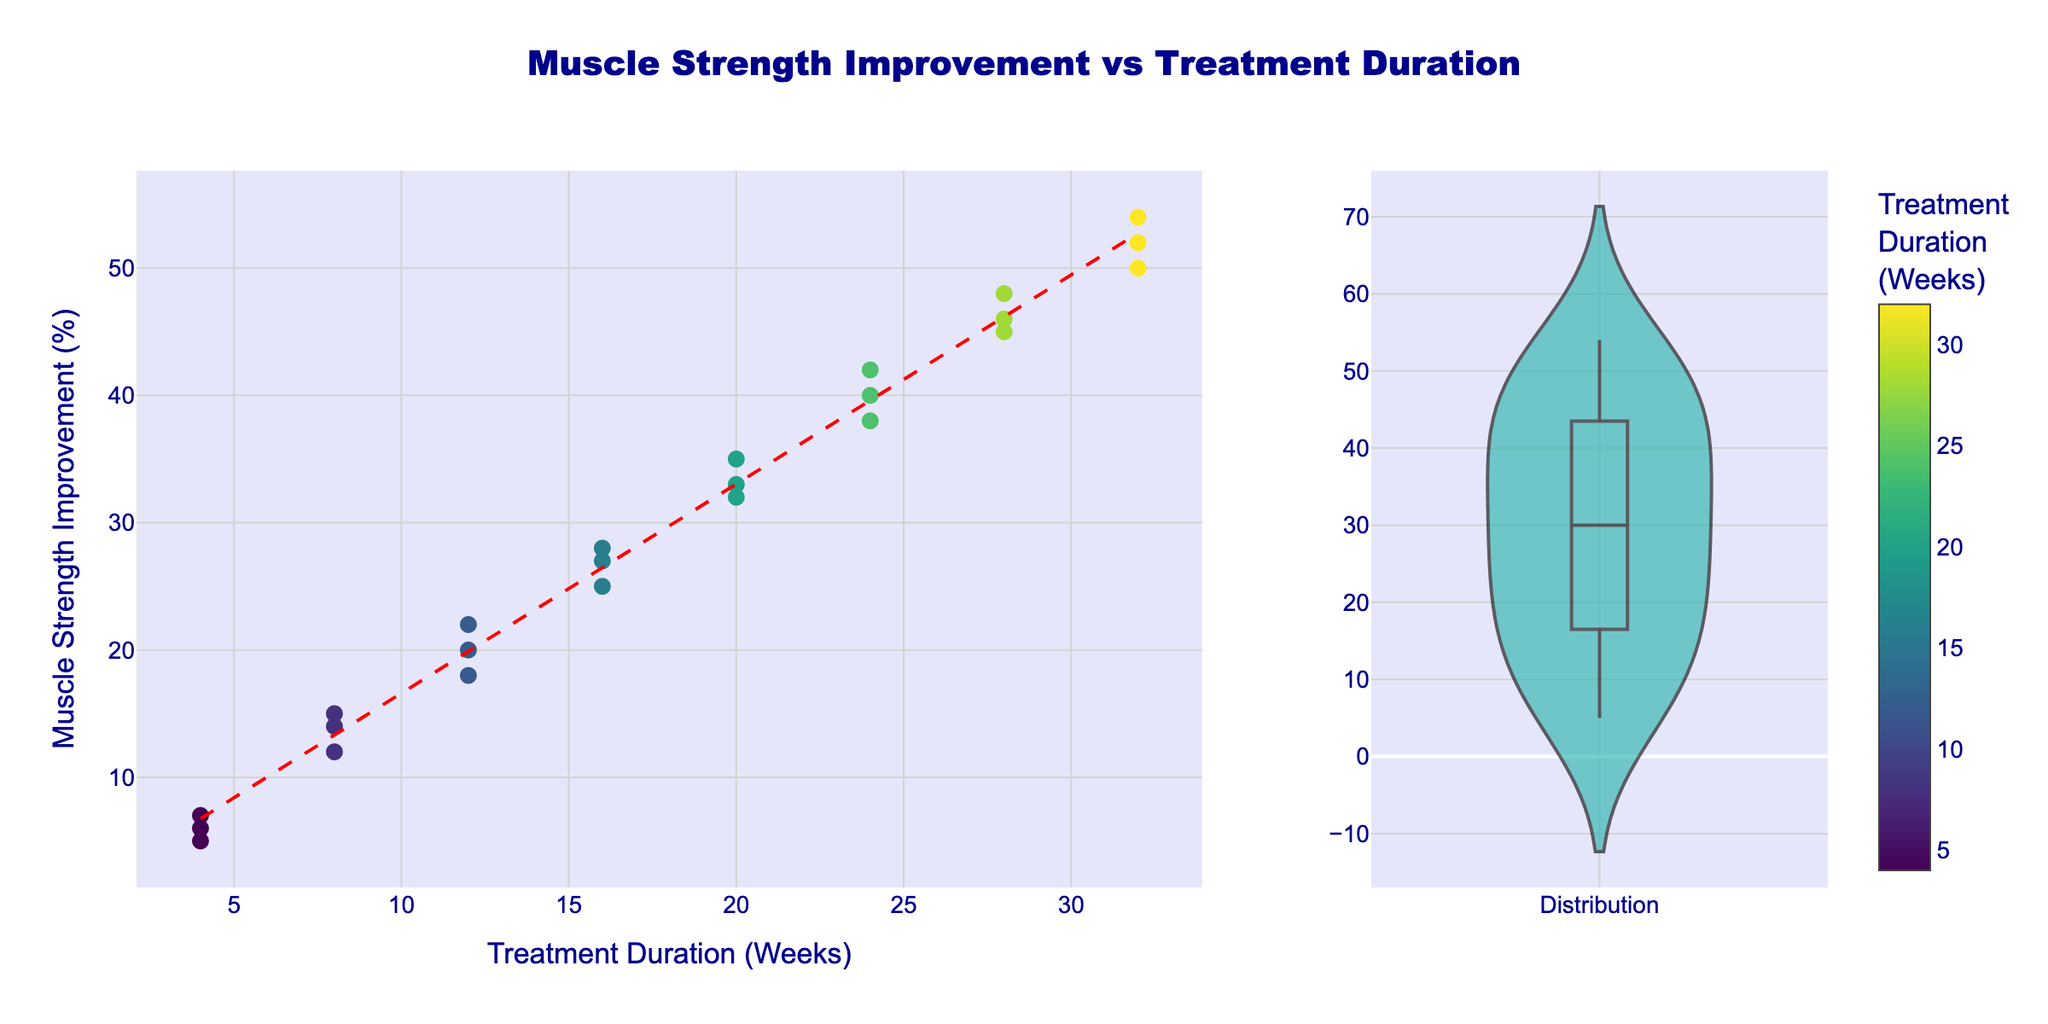What does the title of the figure tell us? The title of the figure is "Muscle Strength Improvement vs Treatment Duration." It indicates that the figure compares the improvement in muscle strength against the duration of various treatments.
Answer: Muscle Strength Improvement vs Treatment Duration What is the color used for the scatter plot points? The scatter plot points are colored using a gradient that corresponds to the treatment duration in weeks, with colors on the 'Viridis' scale ranging from blue to yellow.
Answer: Blue to Yellow How many weeks of treatment show the highest muscle strength improvement? By looking at the scatter plot, we see that the highest muscle strength improvement percentages are associated with the 32-week treatment duration.
Answer: 32 weeks What is the range of muscle strength improvement percentages observed in the violin plot? The violin plot shows the distribution of muscle strength improvement percentages. Observing the ranges, the percentages range from about 5% to 54%.
Answer: 5% to 54% Is there a trendline in the scatter plot? If yes, what does it show? Yes, there is a red dashed trendline in the scatter plot. It shows a positive relationship between treatment duration and muscle strength improvement, indicating that longer treatment durations tend to result in higher muscle strength improvements.
Answer: Positive relationship between duration and improvement What is the improvement range for an 8-week treatment? The scatter plot shows that the muscle strength improvement percentages for the 8-week treatment duration range from 12% to 15%.
Answer: 12% to 15% Which treatment duration displays the most significant variability in muscle strength improvement? The violin plot shows the spread of data, and the 24-week treatment duration has points from 38% to 42%, indicating significant variability.
Answer: 24 weeks What can be inferred about the effectiveness of treatments longer than 16 weeks? Observing both the scatter plot with individual data points and the trendline, we can infer that treatments longer than 16 weeks generally result in muscle strength improvements of above 25%, with continuous increments per additional duration.
Answer: Improvements above 25% How does the muscle strength improvement percentage for a 20-week treatment compare to a 12-week treatment? The scatter plot shows that muscle strength improvement percentages for 20 weeks range from 32% to 35%, while for 12 weeks, they range from 18% to 22%. This means that a 20-week treatment generally results in higher muscle strength improvement than a 12-week treatment.
Answer: 20-week treatment has higher improvement What does the boxes in the violin plot represent? The boxes visible in the violin plot represent the interquartile range (IQR) of the muscle strength improvement data, showing the spread between the 25th and 75th percentiles.
Answer: Interquartile range (IQR) 